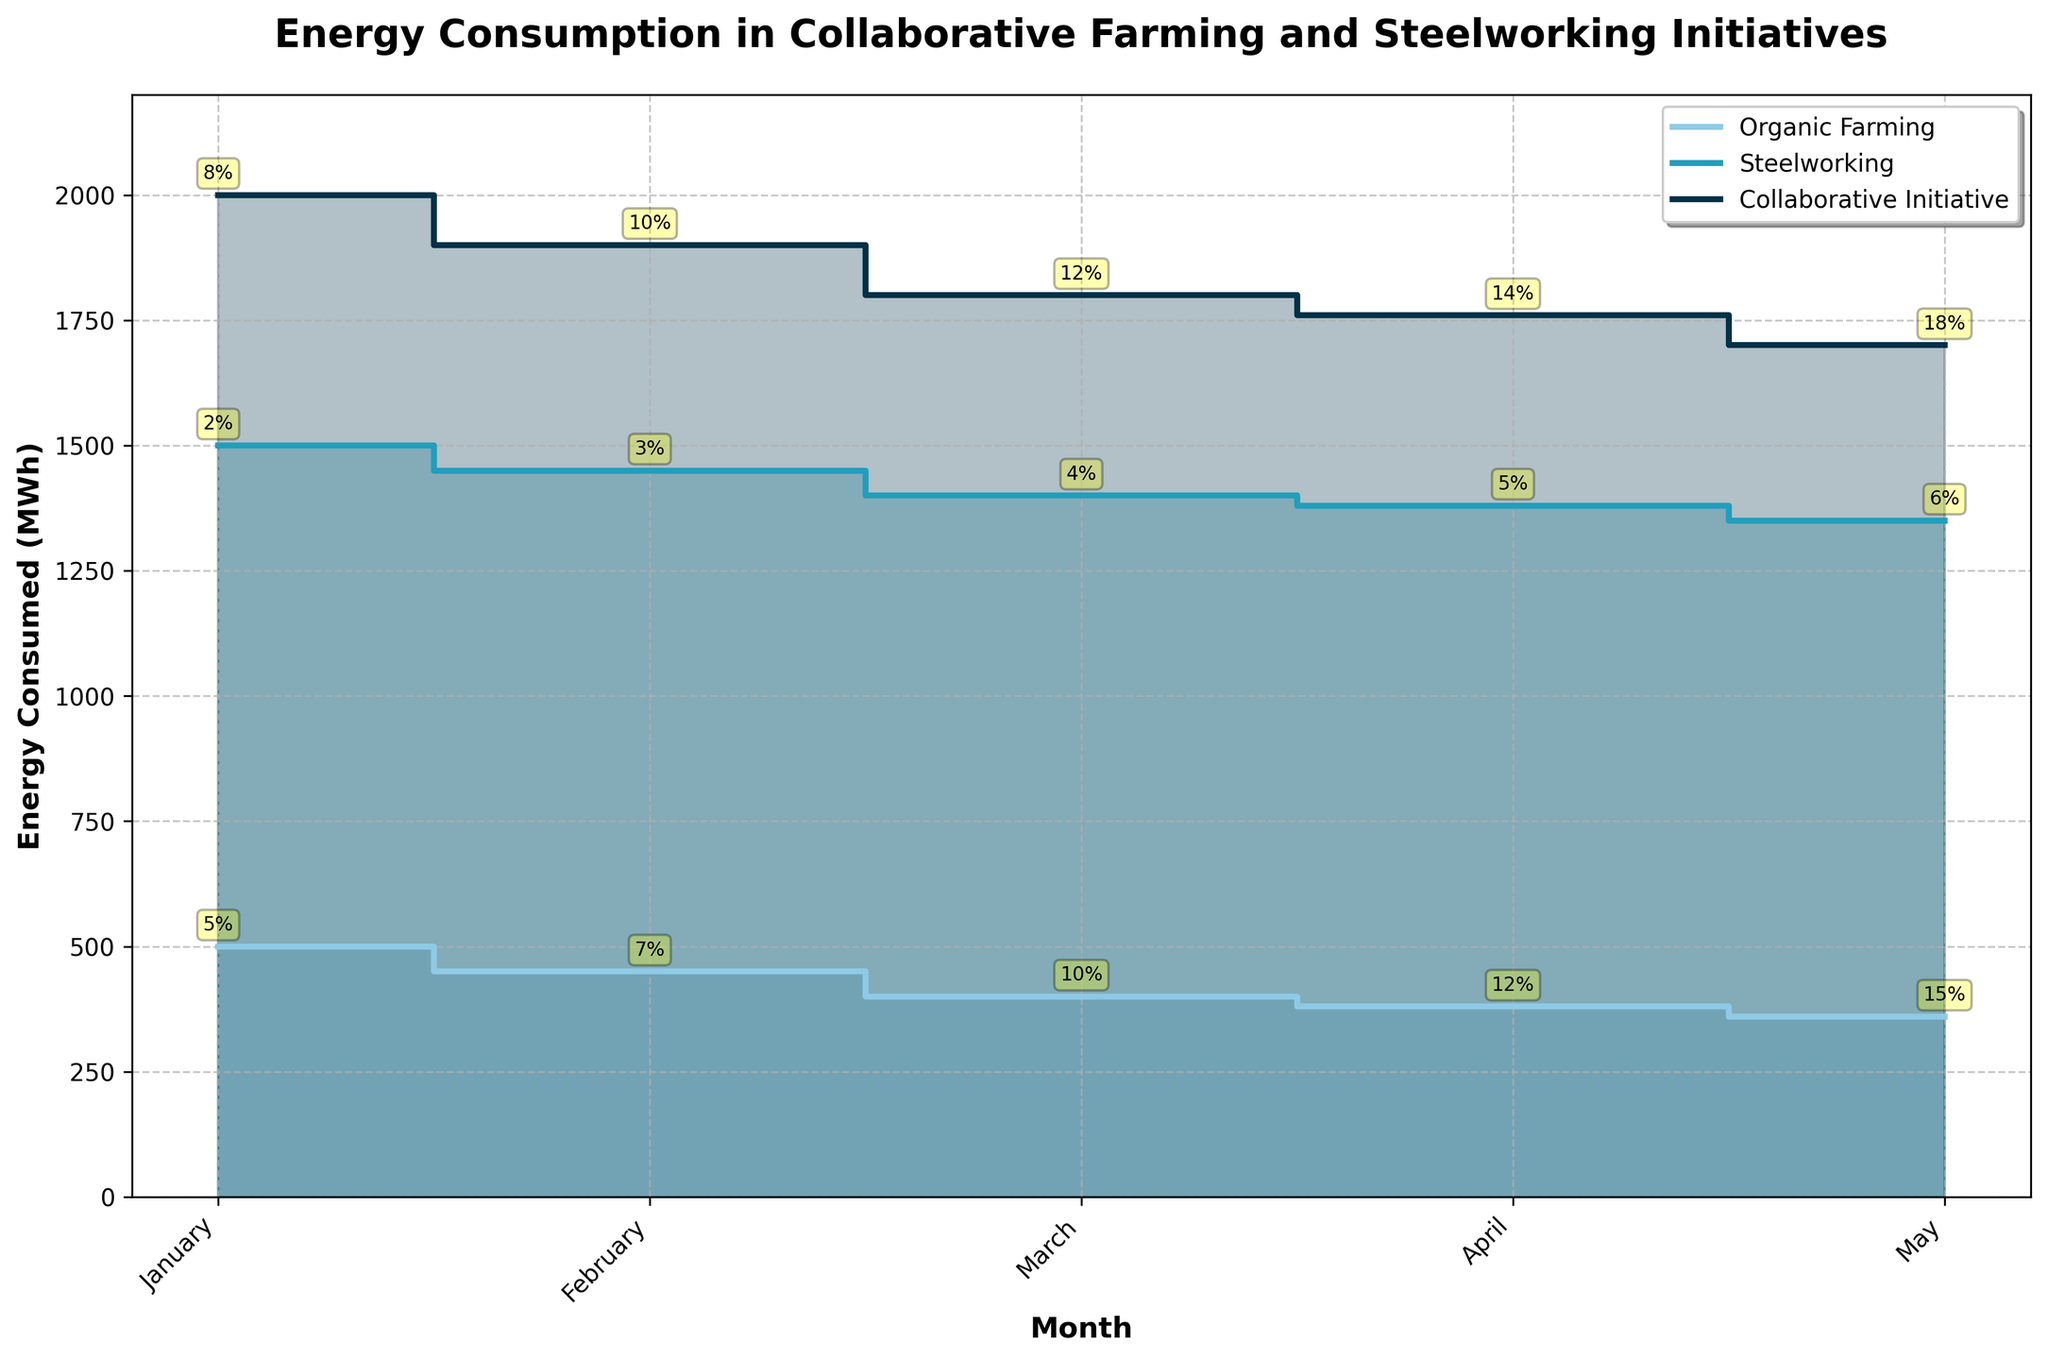What is the title of the plot? The title is displayed at the top of the plot. It states the main subject the plot is illustrating.
Answer: Energy Consumption in Collaborative Farming and Steelworking Initiatives Which month had the lowest energy consumption for the Organic Farming sector? By examining the 'Organic Farming' line on the plot, you can see that the lowest point corresponds to May.
Answer: May How much energy was consumed by the Steelworking sector in March? Look at the 'Steelworking' line and find the point corresponding to March. The y-axis value at this point shows the energy consumed.
Answer: 1400 MWh What percentage of efficiency improvement was achieved by the Collaborative Initiative in February? Efficiency percentages are annotated near data points. For February in the Collaborative Initiative, it shows 10%.
Answer: 10% Which sector had the highest energy consumption across all months? Identify the line that reaches the highest points on the y-axis. The Collaborative Initiative consistently shows the highest values.
Answer: Collaborative Initiative In April, which sector had a closer energy consumption to the other: Organic Farming or Steelworking? Compare the y-axis values for both Organic Farming and Steelworking in April. Organic Farming (380 MWh) is closer to Steelworking (1380 MWh).
Answer: Steelworking By how much did energy consumption drop from January to May in the Collaborative Initiative? Subtract May's energy consumption value from January's energy consumption value for the Collaborative Initiative (2000 MWh - 1700 MWh).
Answer: 300 MWh Between February and March, which sector shows the largest decrease in energy consumption? Compare the difference between February and March for each sector. The Collaborative Initiative shows a decrease of 100 MWh (1900 MWh to 1800 MWh).
Answer: Collaborative Initiative What are the efficiency improvements percentages annotated in the plot for Organic Farming in March and April respectively? Look at the annotations near the March and April points for Organic Farming. March shows 10% and April shows 12%.
Answer: 10% and 12% What is the overall trend in energy consumption for the Organic Farming sector over the five months? Analyze the line for Organic Farming from January to May; it shows a decreasing trend.
Answer: Decreasing 